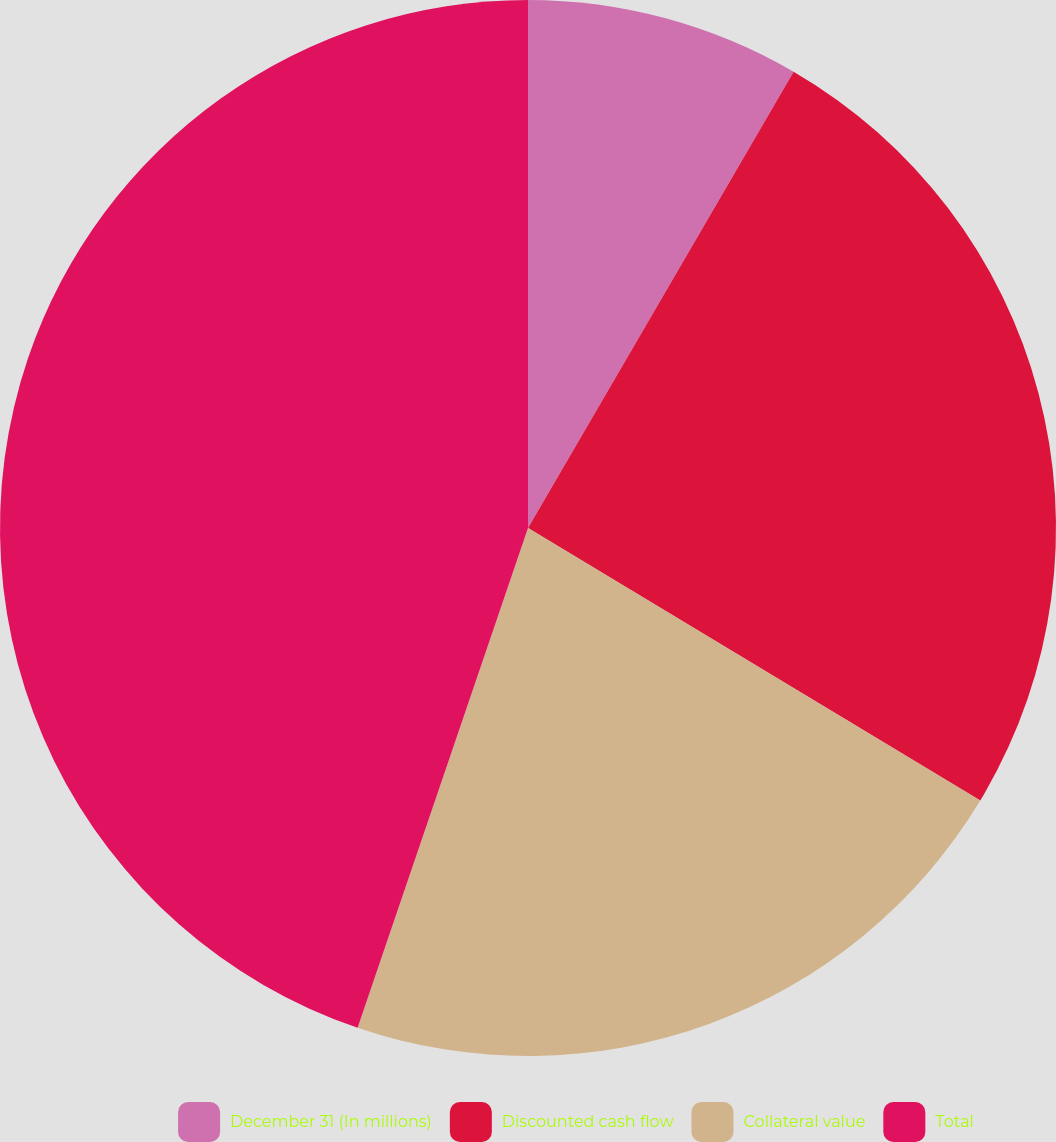Convert chart to OTSL. <chart><loc_0><loc_0><loc_500><loc_500><pie_chart><fcel>December 31 (In millions)<fcel>Discounted cash flow<fcel>Collateral value<fcel>Total<nl><fcel>8.39%<fcel>25.24%<fcel>21.6%<fcel>44.77%<nl></chart> 